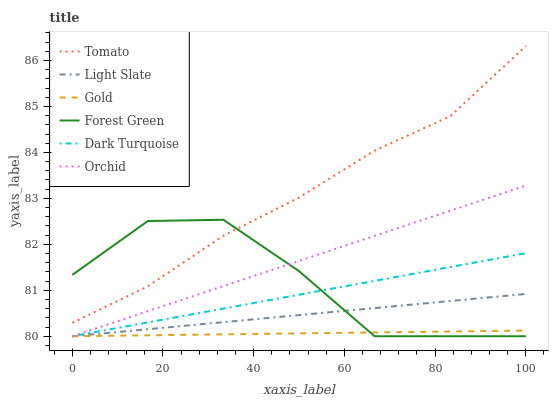Does Gold have the minimum area under the curve?
Answer yes or no. Yes. Does Tomato have the maximum area under the curve?
Answer yes or no. Yes. Does Light Slate have the minimum area under the curve?
Answer yes or no. No. Does Light Slate have the maximum area under the curve?
Answer yes or no. No. Is Light Slate the smoothest?
Answer yes or no. Yes. Is Forest Green the roughest?
Answer yes or no. Yes. Is Gold the smoothest?
Answer yes or no. No. Is Gold the roughest?
Answer yes or no. No. Does Gold have the lowest value?
Answer yes or no. Yes. Does Tomato have the highest value?
Answer yes or no. Yes. Does Light Slate have the highest value?
Answer yes or no. No. Is Light Slate less than Tomato?
Answer yes or no. Yes. Is Tomato greater than Gold?
Answer yes or no. Yes. Does Light Slate intersect Dark Turquoise?
Answer yes or no. Yes. Is Light Slate less than Dark Turquoise?
Answer yes or no. No. Is Light Slate greater than Dark Turquoise?
Answer yes or no. No. Does Light Slate intersect Tomato?
Answer yes or no. No. 